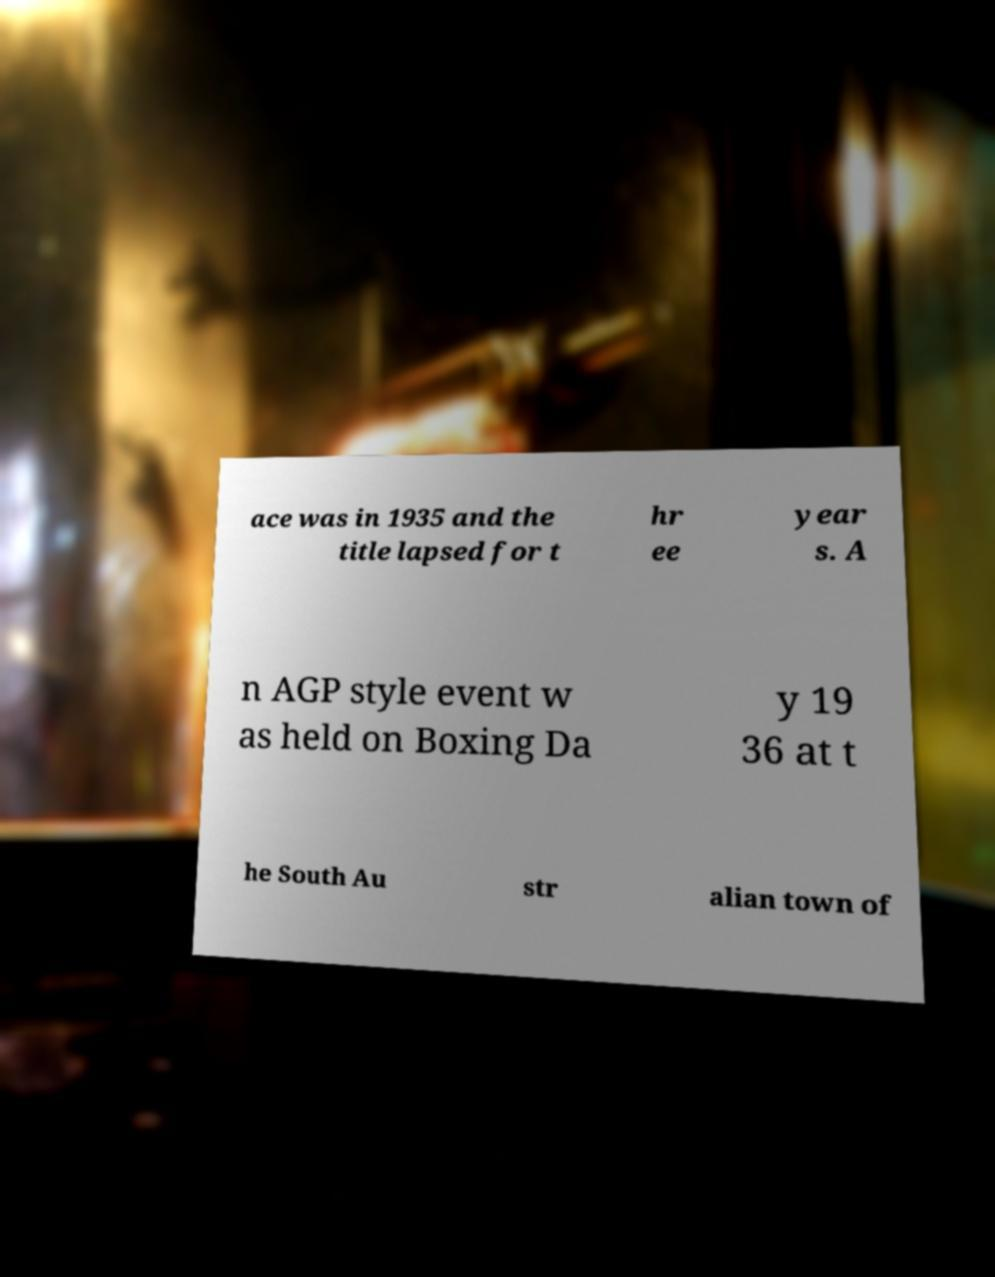There's text embedded in this image that I need extracted. Can you transcribe it verbatim? ace was in 1935 and the title lapsed for t hr ee year s. A n AGP style event w as held on Boxing Da y 19 36 at t he South Au str alian town of 